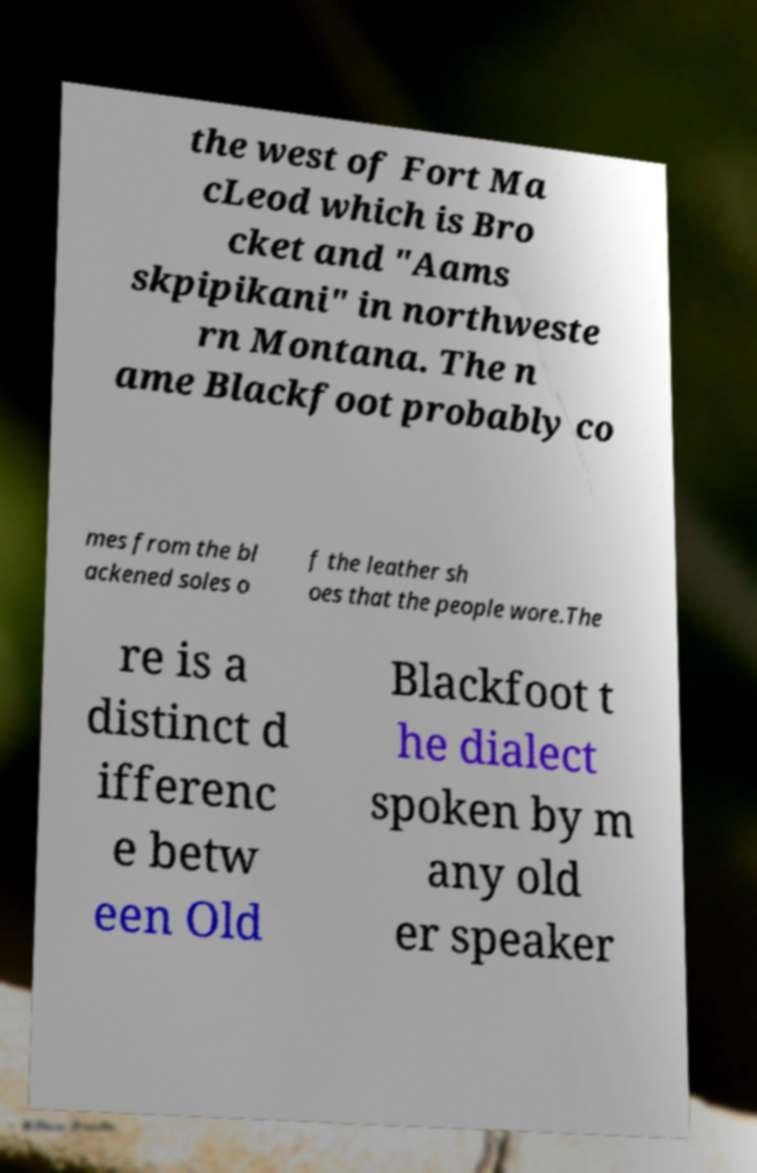Please identify and transcribe the text found in this image. the west of Fort Ma cLeod which is Bro cket and "Aams skpipikani" in northweste rn Montana. The n ame Blackfoot probably co mes from the bl ackened soles o f the leather sh oes that the people wore.The re is a distinct d ifferenc e betw een Old Blackfoot t he dialect spoken by m any old er speaker 